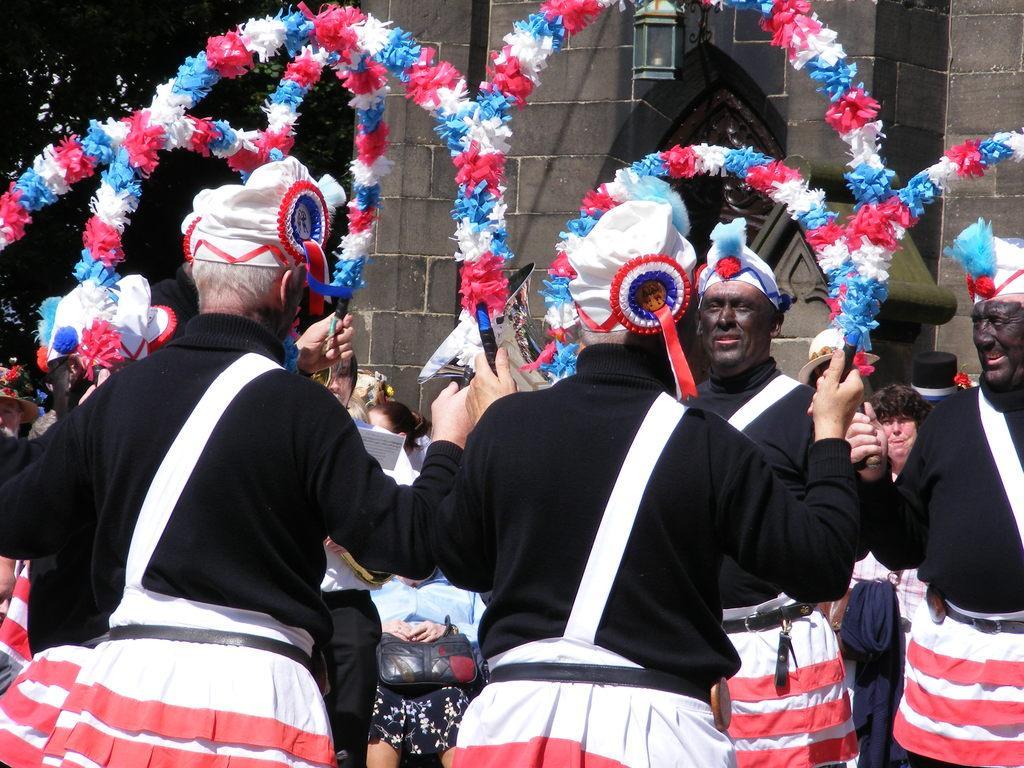Describe this image in one or two sentences. A group of people are performing different actions, they wore black color coats and white and red color shorts. In the middle it is a stone wall. 